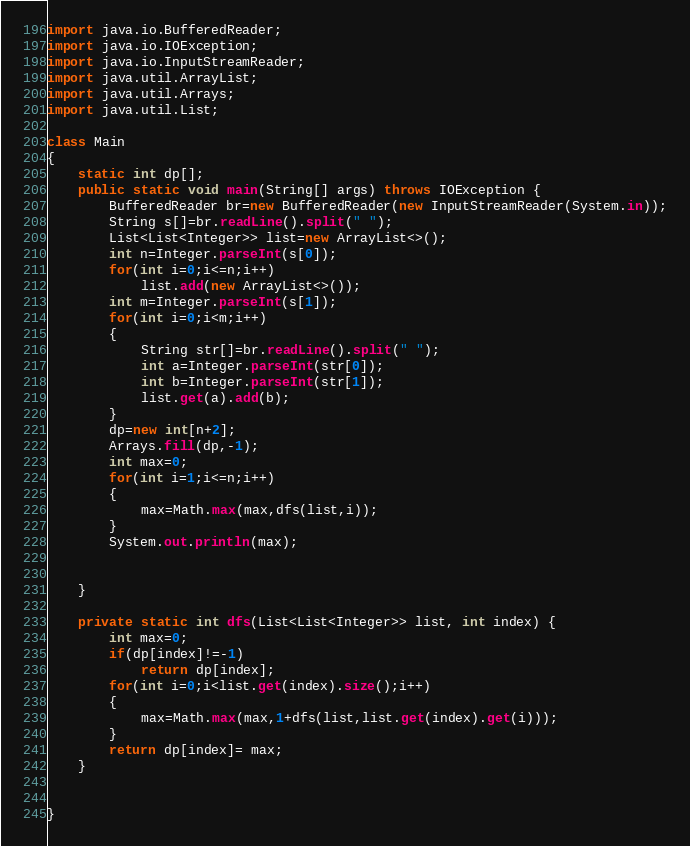<code> <loc_0><loc_0><loc_500><loc_500><_Java_>import java.io.BufferedReader;
import java.io.IOException;
import java.io.InputStreamReader;
import java.util.ArrayList;
import java.util.Arrays;
import java.util.List;

class Main
{
    static int dp[];
    public static void main(String[] args) throws IOException {
        BufferedReader br=new BufferedReader(new InputStreamReader(System.in));
        String s[]=br.readLine().split(" ");
        List<List<Integer>> list=new ArrayList<>();
        int n=Integer.parseInt(s[0]);
        for(int i=0;i<=n;i++)
            list.add(new ArrayList<>());
        int m=Integer.parseInt(s[1]);
        for(int i=0;i<m;i++)
        {
            String str[]=br.readLine().split(" ");
            int a=Integer.parseInt(str[0]);
            int b=Integer.parseInt(str[1]);
            list.get(a).add(b);
        }
        dp=new int[n+2];
        Arrays.fill(dp,-1);
        int max=0;
        for(int i=1;i<=n;i++)
        {
            max=Math.max(max,dfs(list,i));
        }
        System.out.println(max);


    }

    private static int dfs(List<List<Integer>> list, int index) {
        int max=0;
        if(dp[index]!=-1)
            return dp[index];
        for(int i=0;i<list.get(index).size();i++)
        {
            max=Math.max(max,1+dfs(list,list.get(index).get(i)));
        }
        return dp[index]= max;
    }


}</code> 